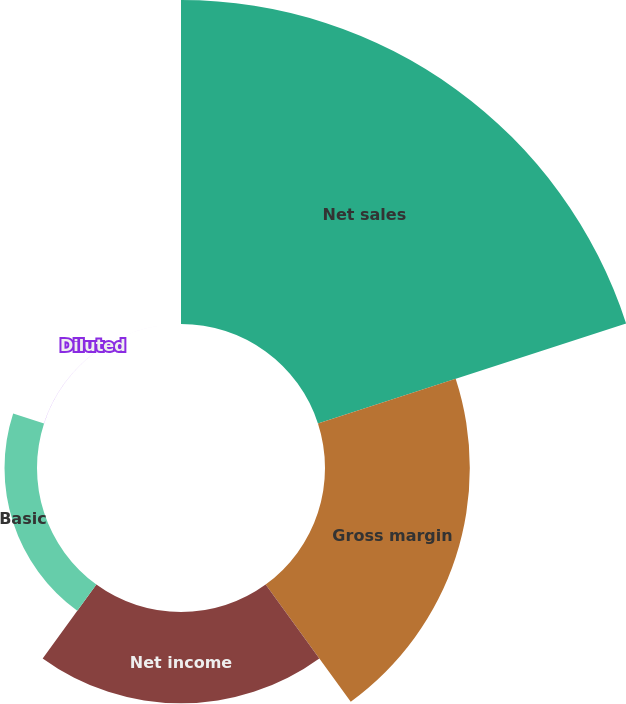Convert chart to OTSL. <chart><loc_0><loc_0><loc_500><loc_500><pie_chart><fcel>Net sales<fcel>Gross margin<fcel>Net income<fcel>Basic<fcel>Diluted<nl><fcel>54.66%<fcel>24.43%<fcel>15.41%<fcel>5.48%<fcel>0.02%<nl></chart> 